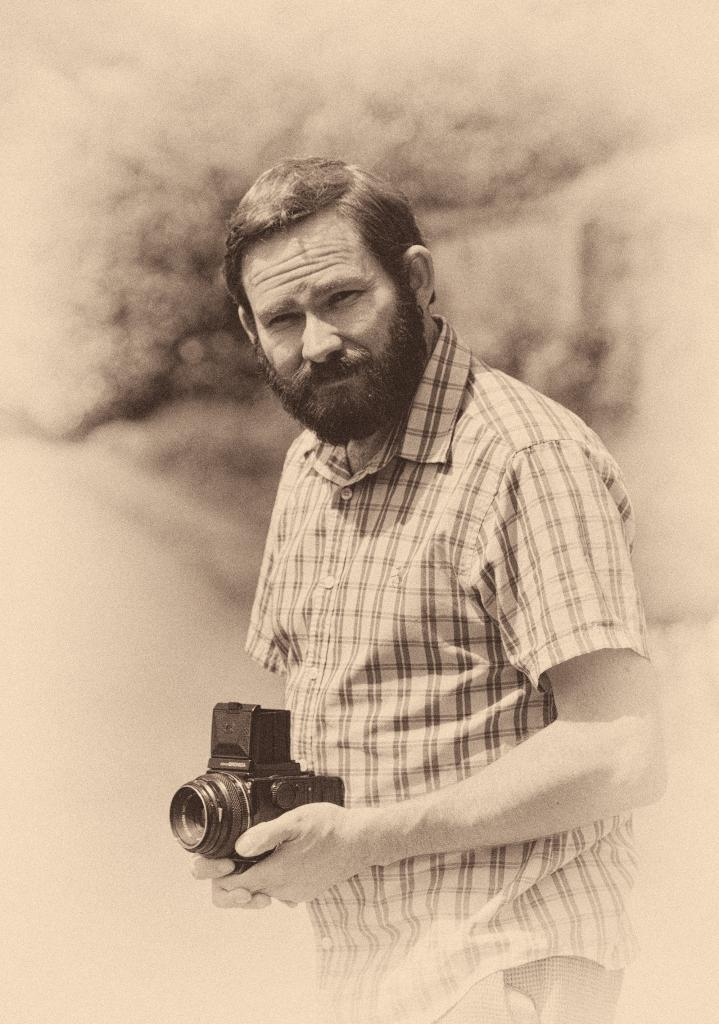What is the main subject of the image? The main subject of the image is a man. Can you describe the man's clothing? The man is wearing a red checkered shirt with a pattern of small squares, commonly referred to as a red checkered shirt. What is the man holding in his hand? The man is holding a camera in his hand. What facial feature does the man have? The man has a beard. What type of jam is the man spreading on the crate in the image? There is no crate or jam present in the image; the man is holding a camera and wearing a red checkered shirt. 